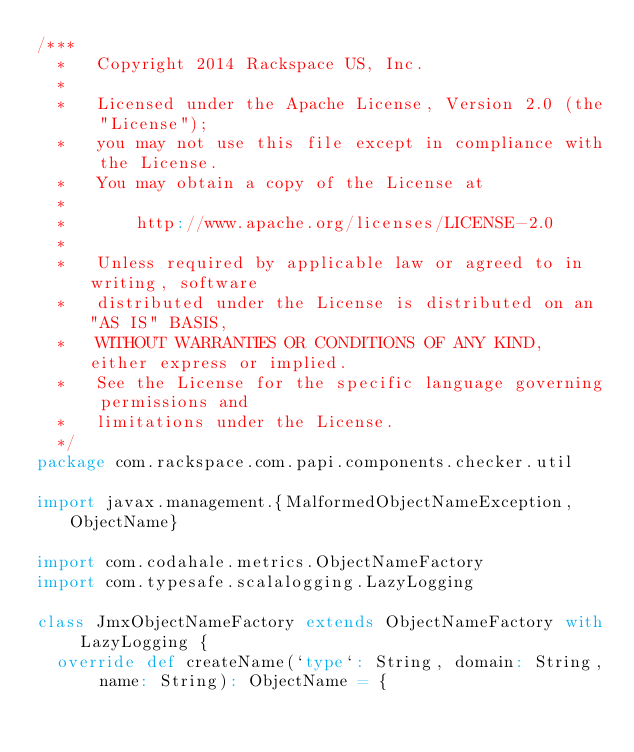<code> <loc_0><loc_0><loc_500><loc_500><_Scala_>/***
  *   Copyright 2014 Rackspace US, Inc.
  *
  *   Licensed under the Apache License, Version 2.0 (the "License");
  *   you may not use this file except in compliance with the License.
  *   You may obtain a copy of the License at
  *
  *       http://www.apache.org/licenses/LICENSE-2.0
  *
  *   Unless required by applicable law or agreed to in writing, software
  *   distributed under the License is distributed on an "AS IS" BASIS,
  *   WITHOUT WARRANTIES OR CONDITIONS OF ANY KIND, either express or implied.
  *   See the License for the specific language governing permissions and
  *   limitations under the License.
  */
package com.rackspace.com.papi.components.checker.util

import javax.management.{MalformedObjectNameException, ObjectName}

import com.codahale.metrics.ObjectNameFactory
import com.typesafe.scalalogging.LazyLogging

class JmxObjectNameFactory extends ObjectNameFactory with LazyLogging {
  override def createName(`type`: String, domain: String, name: String): ObjectName = {</code> 